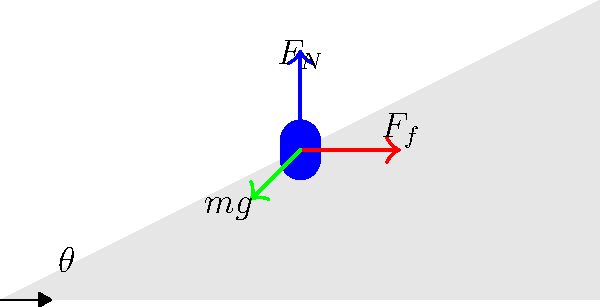In a thrilling game of "Meeples on a Slope" (inspired by Serge Laget's innovative game mechanics), a meeple is placed on an inclined game board at an angle $\theta$ to the horizontal. If the coefficient of static friction between the meeple and the board is $\mu_s$, what is the maximum angle $\theta_{max}$ at which the meeple will remain stationary? Let's approach this step-by-step:

1) The forces acting on the meeple are:
   - Weight ($mg$) acting downwards
   - Normal force ($F_N$) perpendicular to the board
   - Friction force ($F_f$) parallel to the board, opposing motion

2) We can resolve the weight into components parallel and perpendicular to the board:
   - Perpendicular component: $mg \cos\theta$
   - Parallel component: $mg \sin\theta$

3) For equilibrium, the normal force must equal the perpendicular component of weight:
   $F_N = mg \cos\theta$

4) The maximum friction force is given by:
   $F_f = \mu_s F_N = \mu_s mg \cos\theta$

5) For the meeple to remain stationary, this friction force must be greater than or equal to the parallel component of weight:
   $\mu_s mg \cos\theta \geq mg \sin\theta$

6) Simplifying:
   $\mu_s \cos\theta \geq \sin\theta$

7) Dividing both sides by $\cos\theta$:
   $\mu_s \geq \tan\theta$

8) The maximum angle occurs when this is an equality:
   $\mu_s = \tan\theta_{max}$

9) Therefore:
   $\theta_{max} = \arctan(\mu_s)$

This is the maximum angle at which the meeple will remain stationary on the board.
Answer: $\theta_{max} = \arctan(\mu_s)$ 